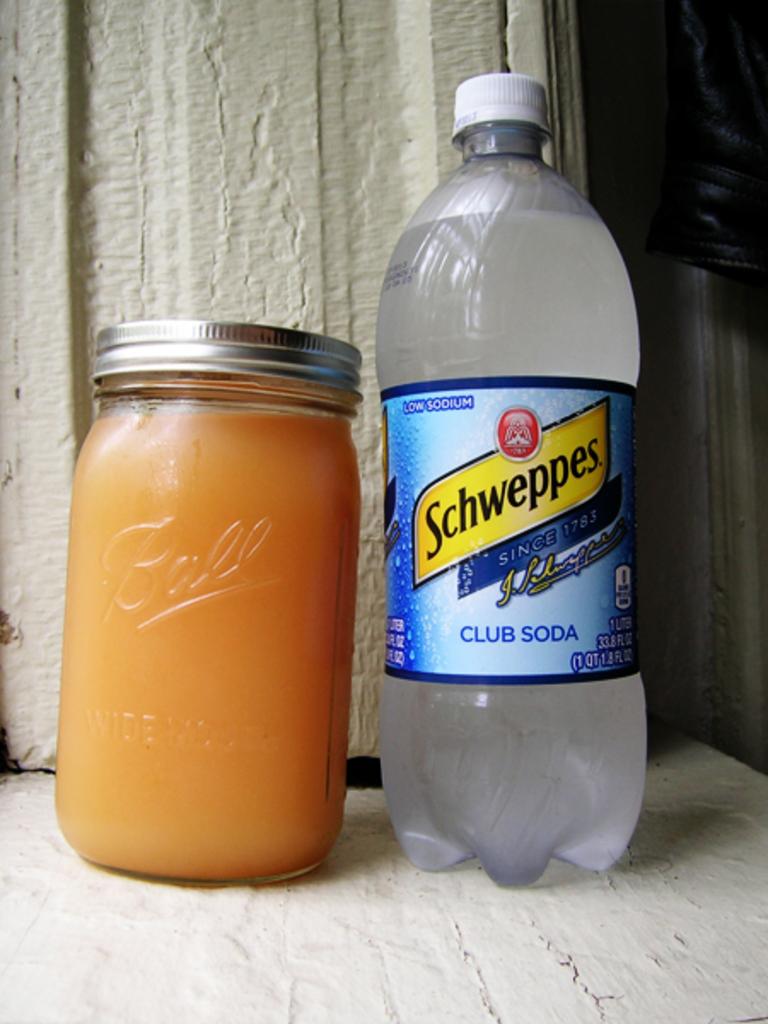What kind of drink is in the bottle?
Your answer should be very brief. Club soda. What brand of glass jar is this?
Offer a terse response. Ball. 